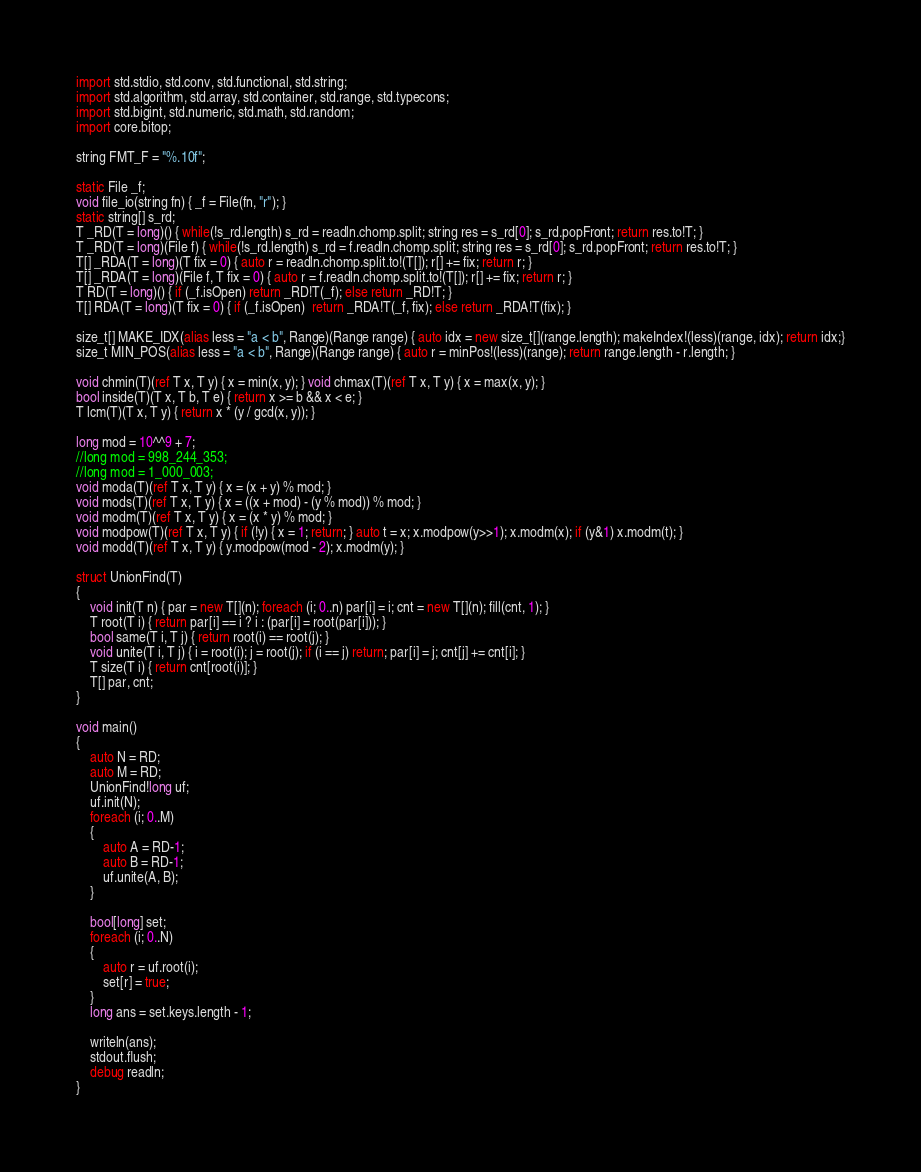Convert code to text. <code><loc_0><loc_0><loc_500><loc_500><_D_>import std.stdio, std.conv, std.functional, std.string;
import std.algorithm, std.array, std.container, std.range, std.typecons;
import std.bigint, std.numeric, std.math, std.random;
import core.bitop;

string FMT_F = "%.10f";

static File _f;
void file_io(string fn) { _f = File(fn, "r"); }
static string[] s_rd;
T _RD(T = long)() { while(!s_rd.length) s_rd = readln.chomp.split; string res = s_rd[0]; s_rd.popFront; return res.to!T; }
T _RD(T = long)(File f) { while(!s_rd.length) s_rd = f.readln.chomp.split; string res = s_rd[0]; s_rd.popFront; return res.to!T; }
T[] _RDA(T = long)(T fix = 0) { auto r = readln.chomp.split.to!(T[]); r[] += fix; return r; }
T[] _RDA(T = long)(File f, T fix = 0) { auto r = f.readln.chomp.split.to!(T[]); r[] += fix; return r; }
T RD(T = long)() { if (_f.isOpen) return _RD!T(_f); else return _RD!T; }
T[] RDA(T = long)(T fix = 0) { if (_f.isOpen)  return _RDA!T(_f, fix); else return _RDA!T(fix); }

size_t[] MAKE_IDX(alias less = "a < b", Range)(Range range) { auto idx = new size_t[](range.length); makeIndex!(less)(range, idx); return idx;}
size_t MIN_POS(alias less = "a < b", Range)(Range range) { auto r = minPos!(less)(range); return range.length - r.length; }

void chmin(T)(ref T x, T y) { x = min(x, y); } void chmax(T)(ref T x, T y) { x = max(x, y); }
bool inside(T)(T x, T b, T e) { return x >= b && x < e; }
T lcm(T)(T x, T y) { return x * (y / gcd(x, y)); }

long mod = 10^^9 + 7;
//long mod = 998_244_353;
//long mod = 1_000_003;
void moda(T)(ref T x, T y) { x = (x + y) % mod; }
void mods(T)(ref T x, T y) { x = ((x + mod) - (y % mod)) % mod; }
void modm(T)(ref T x, T y) { x = (x * y) % mod; }
void modpow(T)(ref T x, T y) { if (!y) { x = 1; return; } auto t = x; x.modpow(y>>1); x.modm(x); if (y&1) x.modm(t); }
void modd(T)(ref T x, T y) { y.modpow(mod - 2); x.modm(y); }

struct UnionFind(T)
{
	void init(T n) { par = new T[](n); foreach (i; 0..n) par[i] = i; cnt = new T[](n); fill(cnt, 1); }
	T root(T i) { return par[i] == i ? i : (par[i] = root(par[i])); }
	bool same(T i, T j) { return root(i) == root(j); }
	void unite(T i, T j) { i = root(i); j = root(j); if (i == j) return; par[i] = j; cnt[j] += cnt[i]; }
	T size(T i) { return cnt[root(i)]; }
	T[] par, cnt;
}

void main()
{
	auto N = RD;
	auto M = RD;
	UnionFind!long uf;
	uf.init(N);
	foreach (i; 0..M)
	{
		auto A = RD-1;
		auto B = RD-1;
		uf.unite(A, B);
	}

	bool[long] set;
	foreach (i; 0..N)
	{
		auto r = uf.root(i);
		set[r] = true;
	}
	long ans = set.keys.length - 1;

	writeln(ans);
	stdout.flush;
	debug readln;
}
</code> 